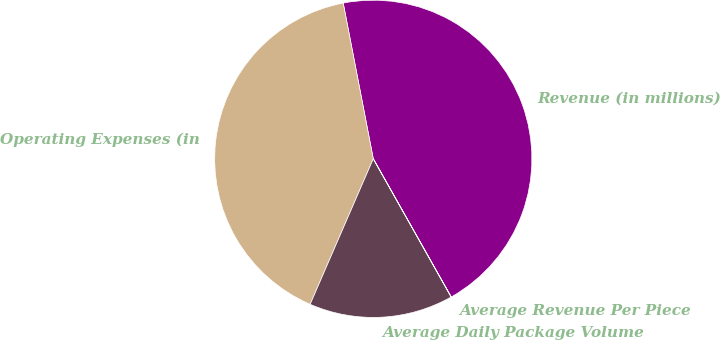<chart> <loc_0><loc_0><loc_500><loc_500><pie_chart><fcel>Revenue (in millions)<fcel>Operating Expenses (in<fcel>Average Daily Package Volume<fcel>Average Revenue Per Piece<nl><fcel>44.86%<fcel>40.45%<fcel>14.68%<fcel>0.01%<nl></chart> 